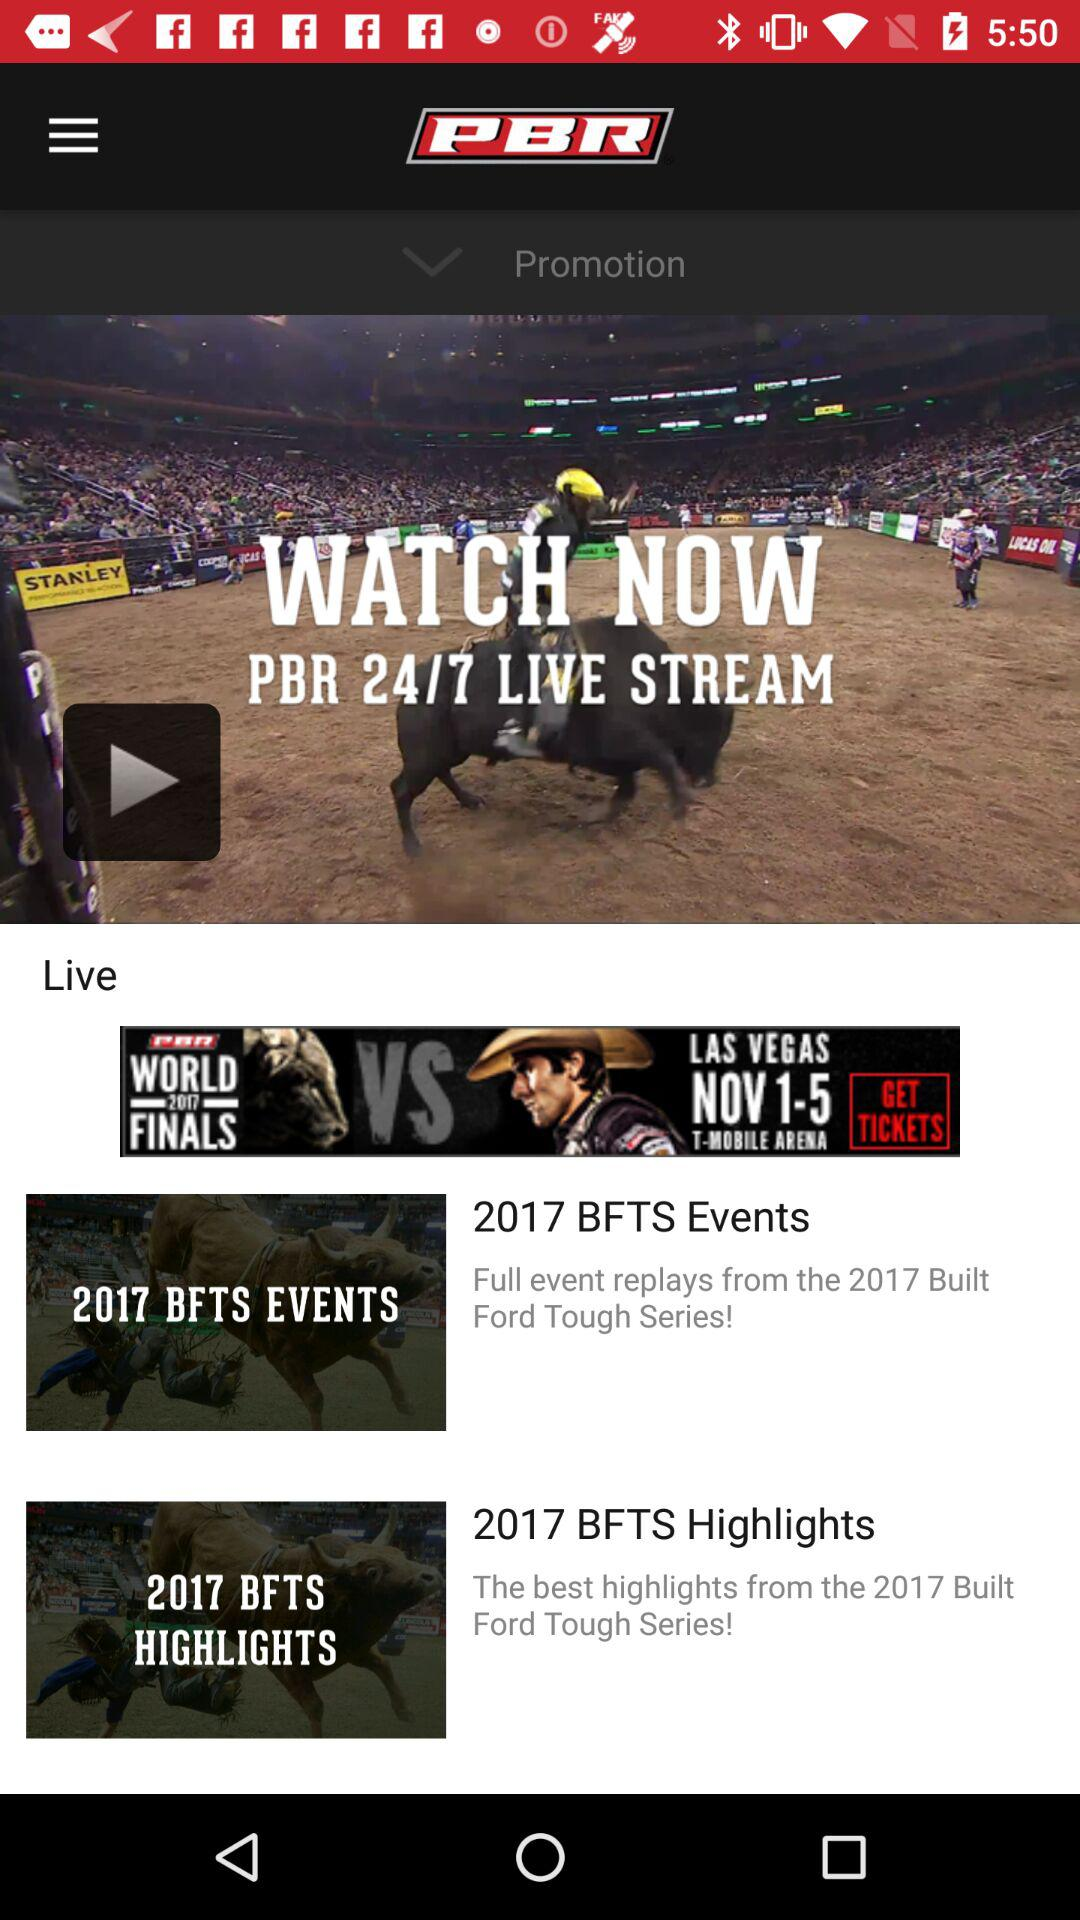What is the name of the application? The name of the application is "PBR Live". 